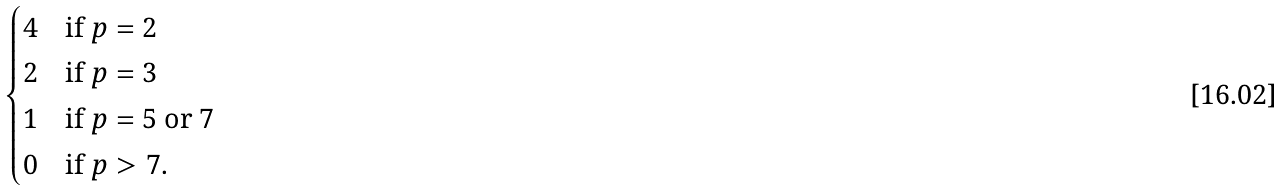Convert formula to latex. <formula><loc_0><loc_0><loc_500><loc_500>\begin{cases} 4 & \text {if $p=2$} \\ 2 & \text {if $p=3$} \\ 1 & \text {if $p=5$ or $7$} \\ 0 & \text {if $p>7$.} \end{cases}</formula> 